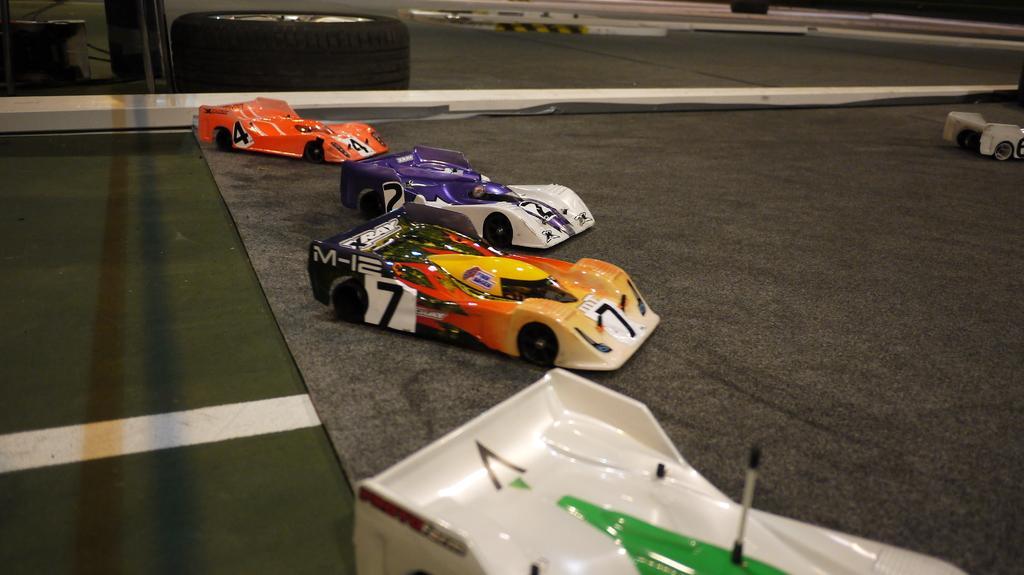Describe this image in one or two sentences. In this image there are a few toy cars on the carpet, which is on the floor. In the background there is like a glass door, behind that there is a tire and other object. 